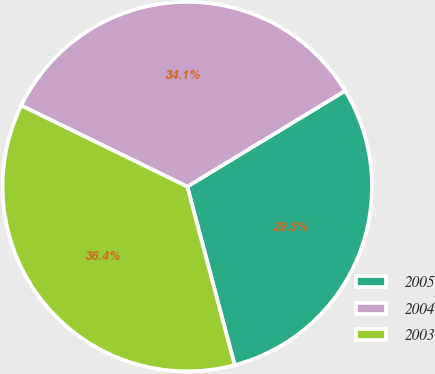Convert chart. <chart><loc_0><loc_0><loc_500><loc_500><pie_chart><fcel>2005<fcel>2004<fcel>2003<nl><fcel>29.55%<fcel>34.09%<fcel>36.36%<nl></chart> 